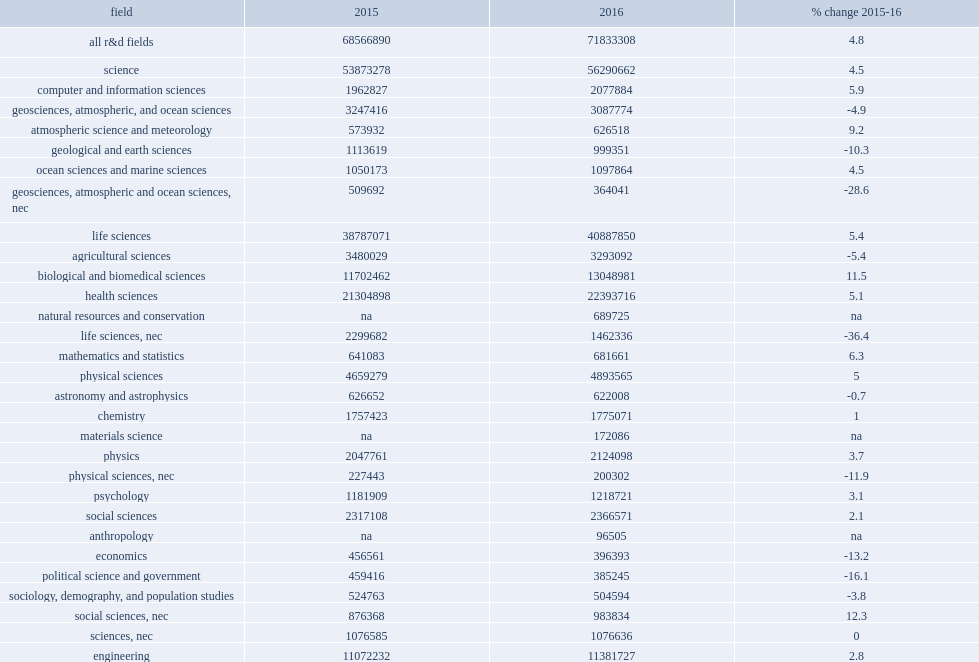How many percent did higher education r&d which has long been heavily concentrated in three fields, which together accounted for of the total spent in fy 2016: health sciences, biological and biomedical sciences, and engineering? 0.651848. Among the broad fields, which fields did r&d expenditures see the largest growth in fy 2016? Non-s&e. 